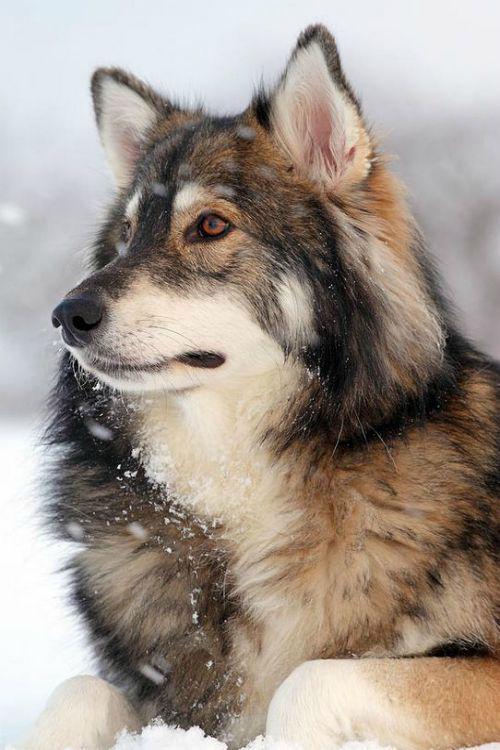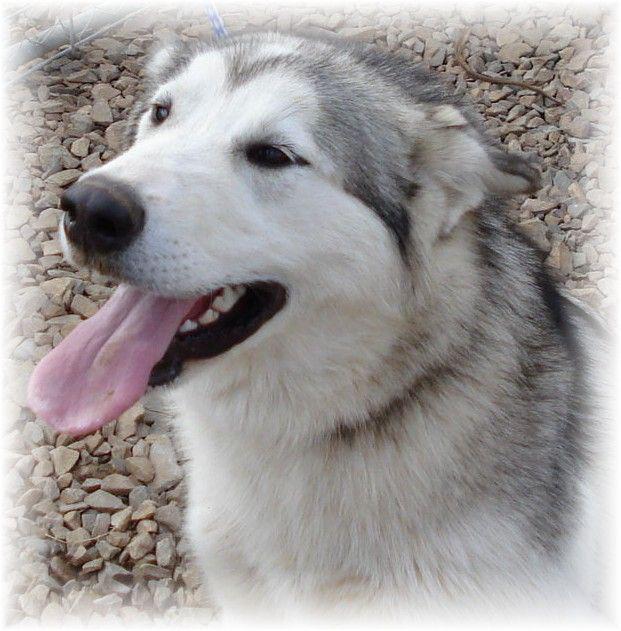The first image is the image on the left, the second image is the image on the right. Given the left and right images, does the statement "The right image includes a dog with its tongue hanging down, and the left image includes a leftward-facing dog with snow on its fur and its paws draped forward." hold true? Answer yes or no. Yes. The first image is the image on the left, the second image is the image on the right. Given the left and right images, does the statement "The left image has exactly one dog with it's mouth closed, the right image has exactly one dog with it's tongue out." hold true? Answer yes or no. Yes. 